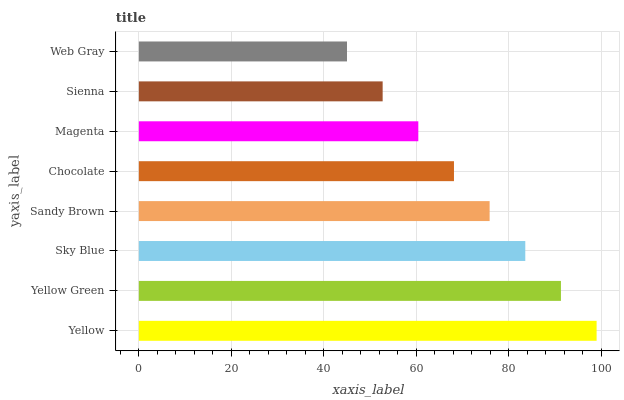Is Web Gray the minimum?
Answer yes or no. Yes. Is Yellow the maximum?
Answer yes or no. Yes. Is Yellow Green the minimum?
Answer yes or no. No. Is Yellow Green the maximum?
Answer yes or no. No. Is Yellow greater than Yellow Green?
Answer yes or no. Yes. Is Yellow Green less than Yellow?
Answer yes or no. Yes. Is Yellow Green greater than Yellow?
Answer yes or no. No. Is Yellow less than Yellow Green?
Answer yes or no. No. Is Sandy Brown the high median?
Answer yes or no. Yes. Is Chocolate the low median?
Answer yes or no. Yes. Is Sienna the high median?
Answer yes or no. No. Is Web Gray the low median?
Answer yes or no. No. 